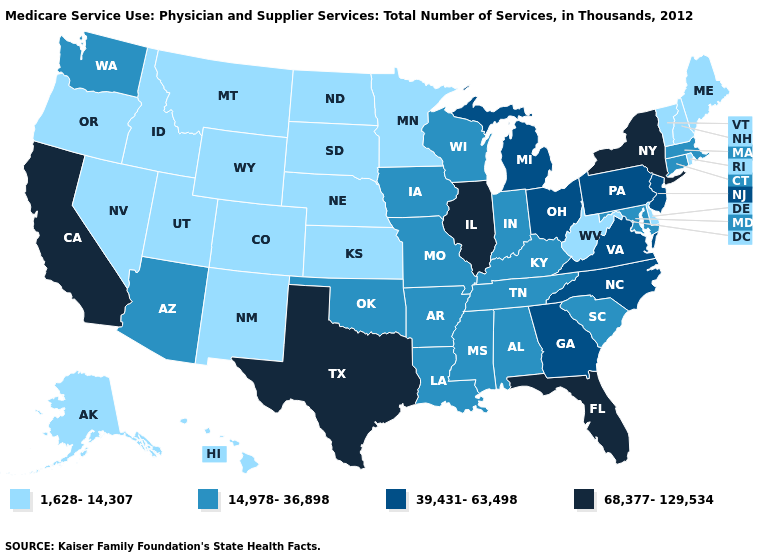Name the states that have a value in the range 39,431-63,498?
Short answer required. Georgia, Michigan, New Jersey, North Carolina, Ohio, Pennsylvania, Virginia. Name the states that have a value in the range 39,431-63,498?
Answer briefly. Georgia, Michigan, New Jersey, North Carolina, Ohio, Pennsylvania, Virginia. Name the states that have a value in the range 14,978-36,898?
Keep it brief. Alabama, Arizona, Arkansas, Connecticut, Indiana, Iowa, Kentucky, Louisiana, Maryland, Massachusetts, Mississippi, Missouri, Oklahoma, South Carolina, Tennessee, Washington, Wisconsin. How many symbols are there in the legend?
Short answer required. 4. What is the value of Pennsylvania?
Answer briefly. 39,431-63,498. Among the states that border Nebraska , does Colorado have the highest value?
Answer briefly. No. Does Nebraska have the highest value in the USA?
Short answer required. No. Name the states that have a value in the range 1,628-14,307?
Write a very short answer. Alaska, Colorado, Delaware, Hawaii, Idaho, Kansas, Maine, Minnesota, Montana, Nebraska, Nevada, New Hampshire, New Mexico, North Dakota, Oregon, Rhode Island, South Dakota, Utah, Vermont, West Virginia, Wyoming. Which states have the lowest value in the South?
Write a very short answer. Delaware, West Virginia. What is the value of California?
Answer briefly. 68,377-129,534. Is the legend a continuous bar?
Concise answer only. No. How many symbols are there in the legend?
Keep it brief. 4. Name the states that have a value in the range 1,628-14,307?
Give a very brief answer. Alaska, Colorado, Delaware, Hawaii, Idaho, Kansas, Maine, Minnesota, Montana, Nebraska, Nevada, New Hampshire, New Mexico, North Dakota, Oregon, Rhode Island, South Dakota, Utah, Vermont, West Virginia, Wyoming. Among the states that border Arkansas , which have the highest value?
Give a very brief answer. Texas. Which states have the lowest value in the USA?
Write a very short answer. Alaska, Colorado, Delaware, Hawaii, Idaho, Kansas, Maine, Minnesota, Montana, Nebraska, Nevada, New Hampshire, New Mexico, North Dakota, Oregon, Rhode Island, South Dakota, Utah, Vermont, West Virginia, Wyoming. 